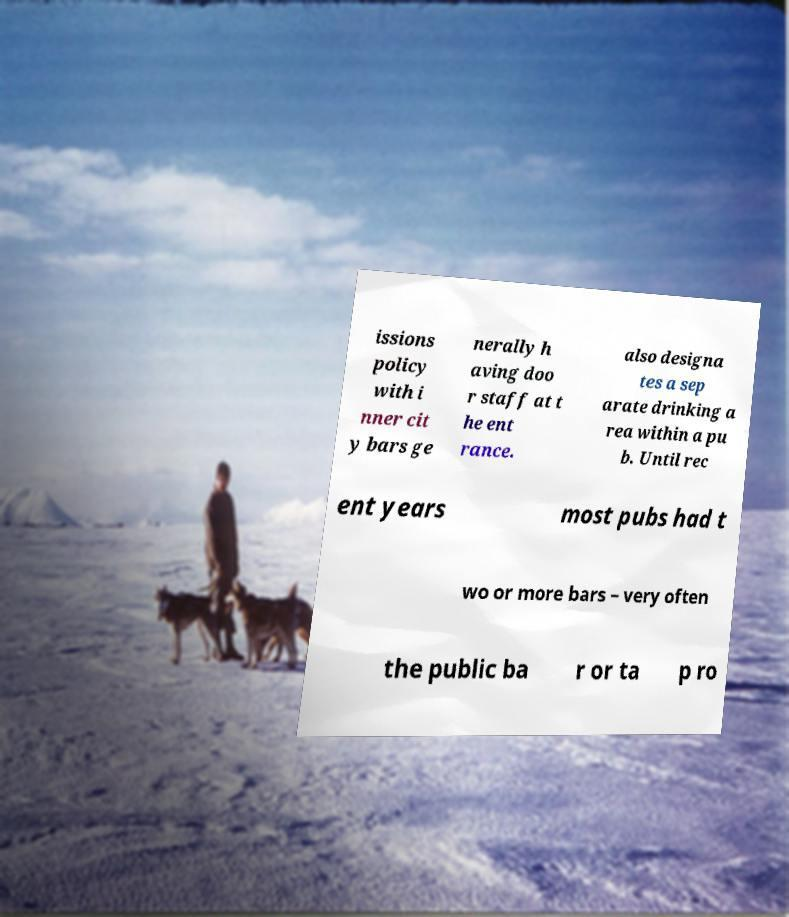What messages or text are displayed in this image? I need them in a readable, typed format. issions policy with i nner cit y bars ge nerally h aving doo r staff at t he ent rance. also designa tes a sep arate drinking a rea within a pu b. Until rec ent years most pubs had t wo or more bars – very often the public ba r or ta p ro 